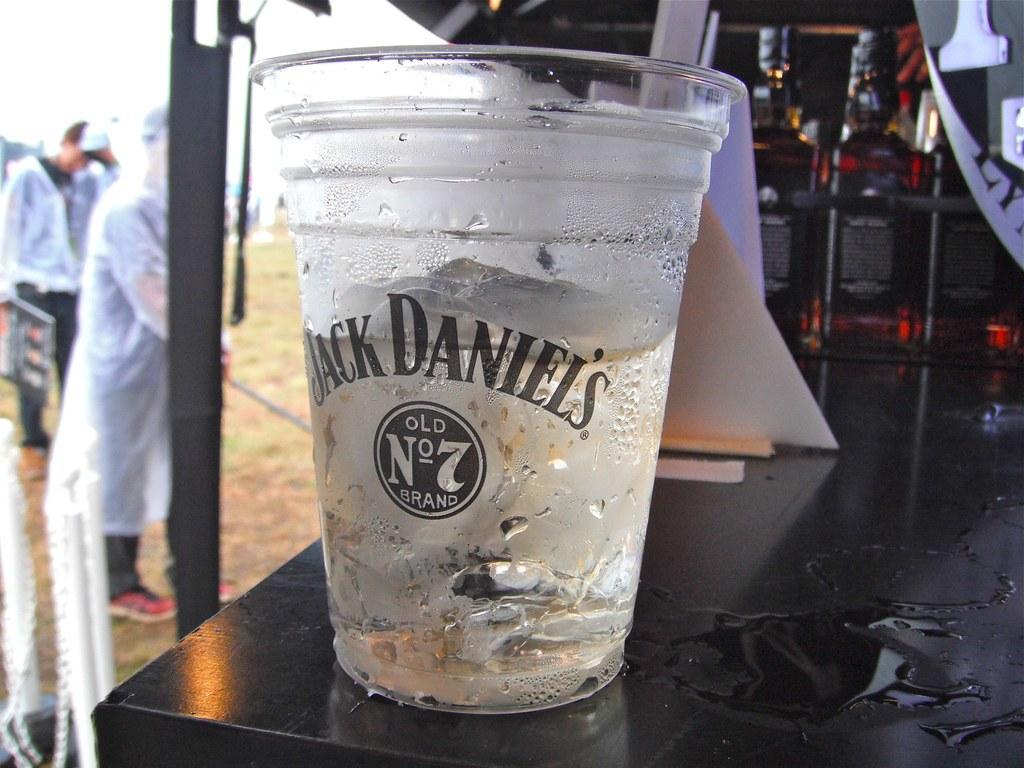In one or two sentences, can you explain what this image depicts? In this picture I can see a glass in the middle, on the left side there are two persons. They are wearing the coats and shoes. 